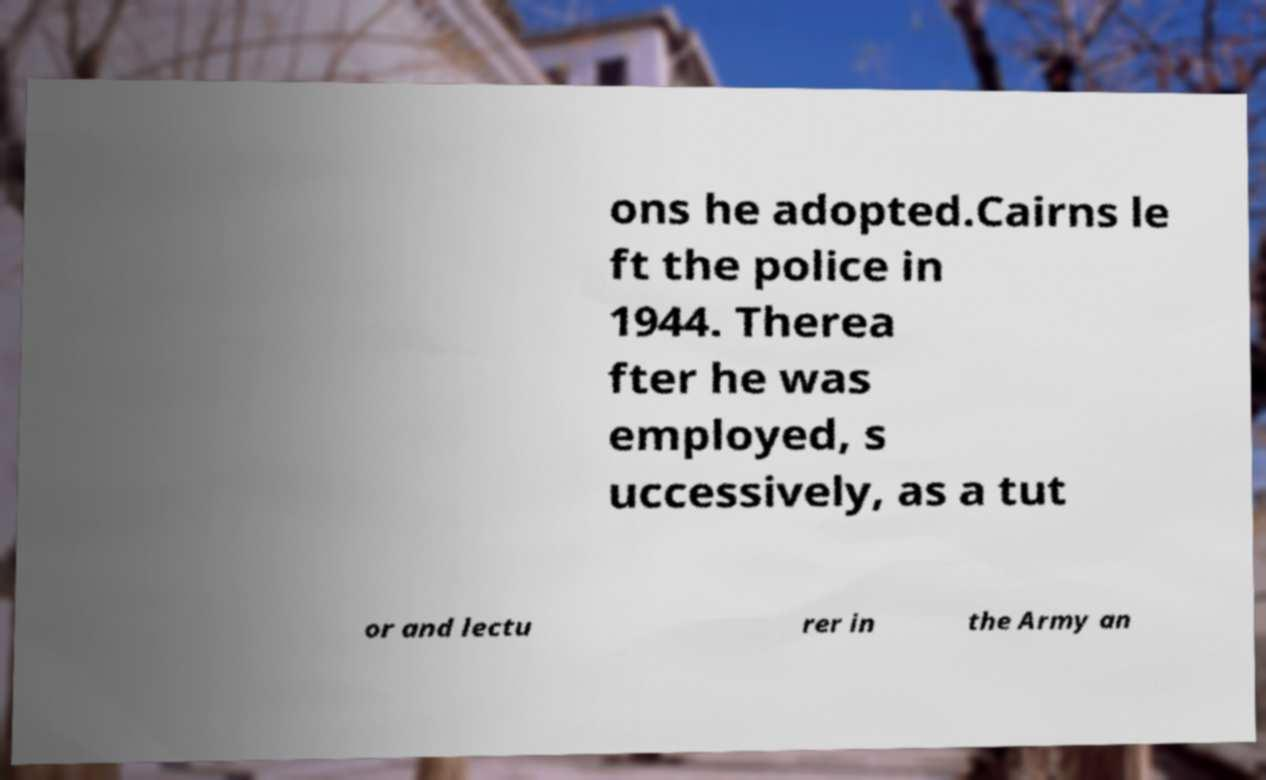Can you accurately transcribe the text from the provided image for me? ons he adopted.Cairns le ft the police in 1944. Therea fter he was employed, s uccessively, as a tut or and lectu rer in the Army an 